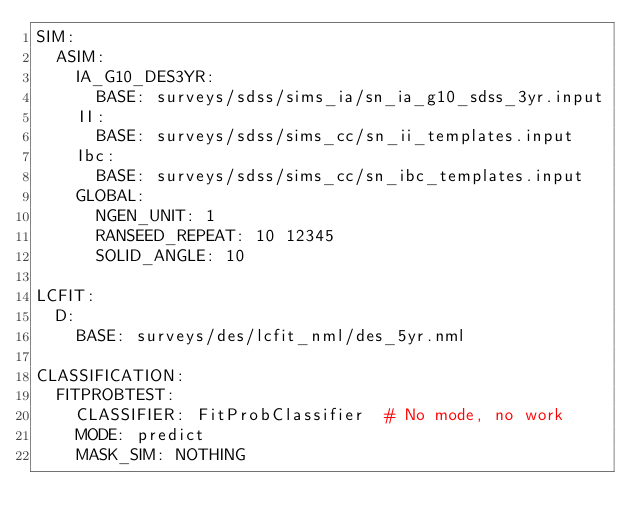<code> <loc_0><loc_0><loc_500><loc_500><_YAML_>SIM:
  ASIM:
    IA_G10_DES3YR:
      BASE: surveys/sdss/sims_ia/sn_ia_g10_sdss_3yr.input
    II:
      BASE: surveys/sdss/sims_cc/sn_ii_templates.input
    Ibc:
      BASE: surveys/sdss/sims_cc/sn_ibc_templates.input
    GLOBAL:
      NGEN_UNIT: 1
      RANSEED_REPEAT: 10 12345
      SOLID_ANGLE: 10

LCFIT:
  D:
    BASE: surveys/des/lcfit_nml/des_5yr.nml

CLASSIFICATION:
  FITPROBTEST:
    CLASSIFIER: FitProbClassifier  # No mode, no work
    MODE: predict
    MASK_SIM: NOTHING
</code> 